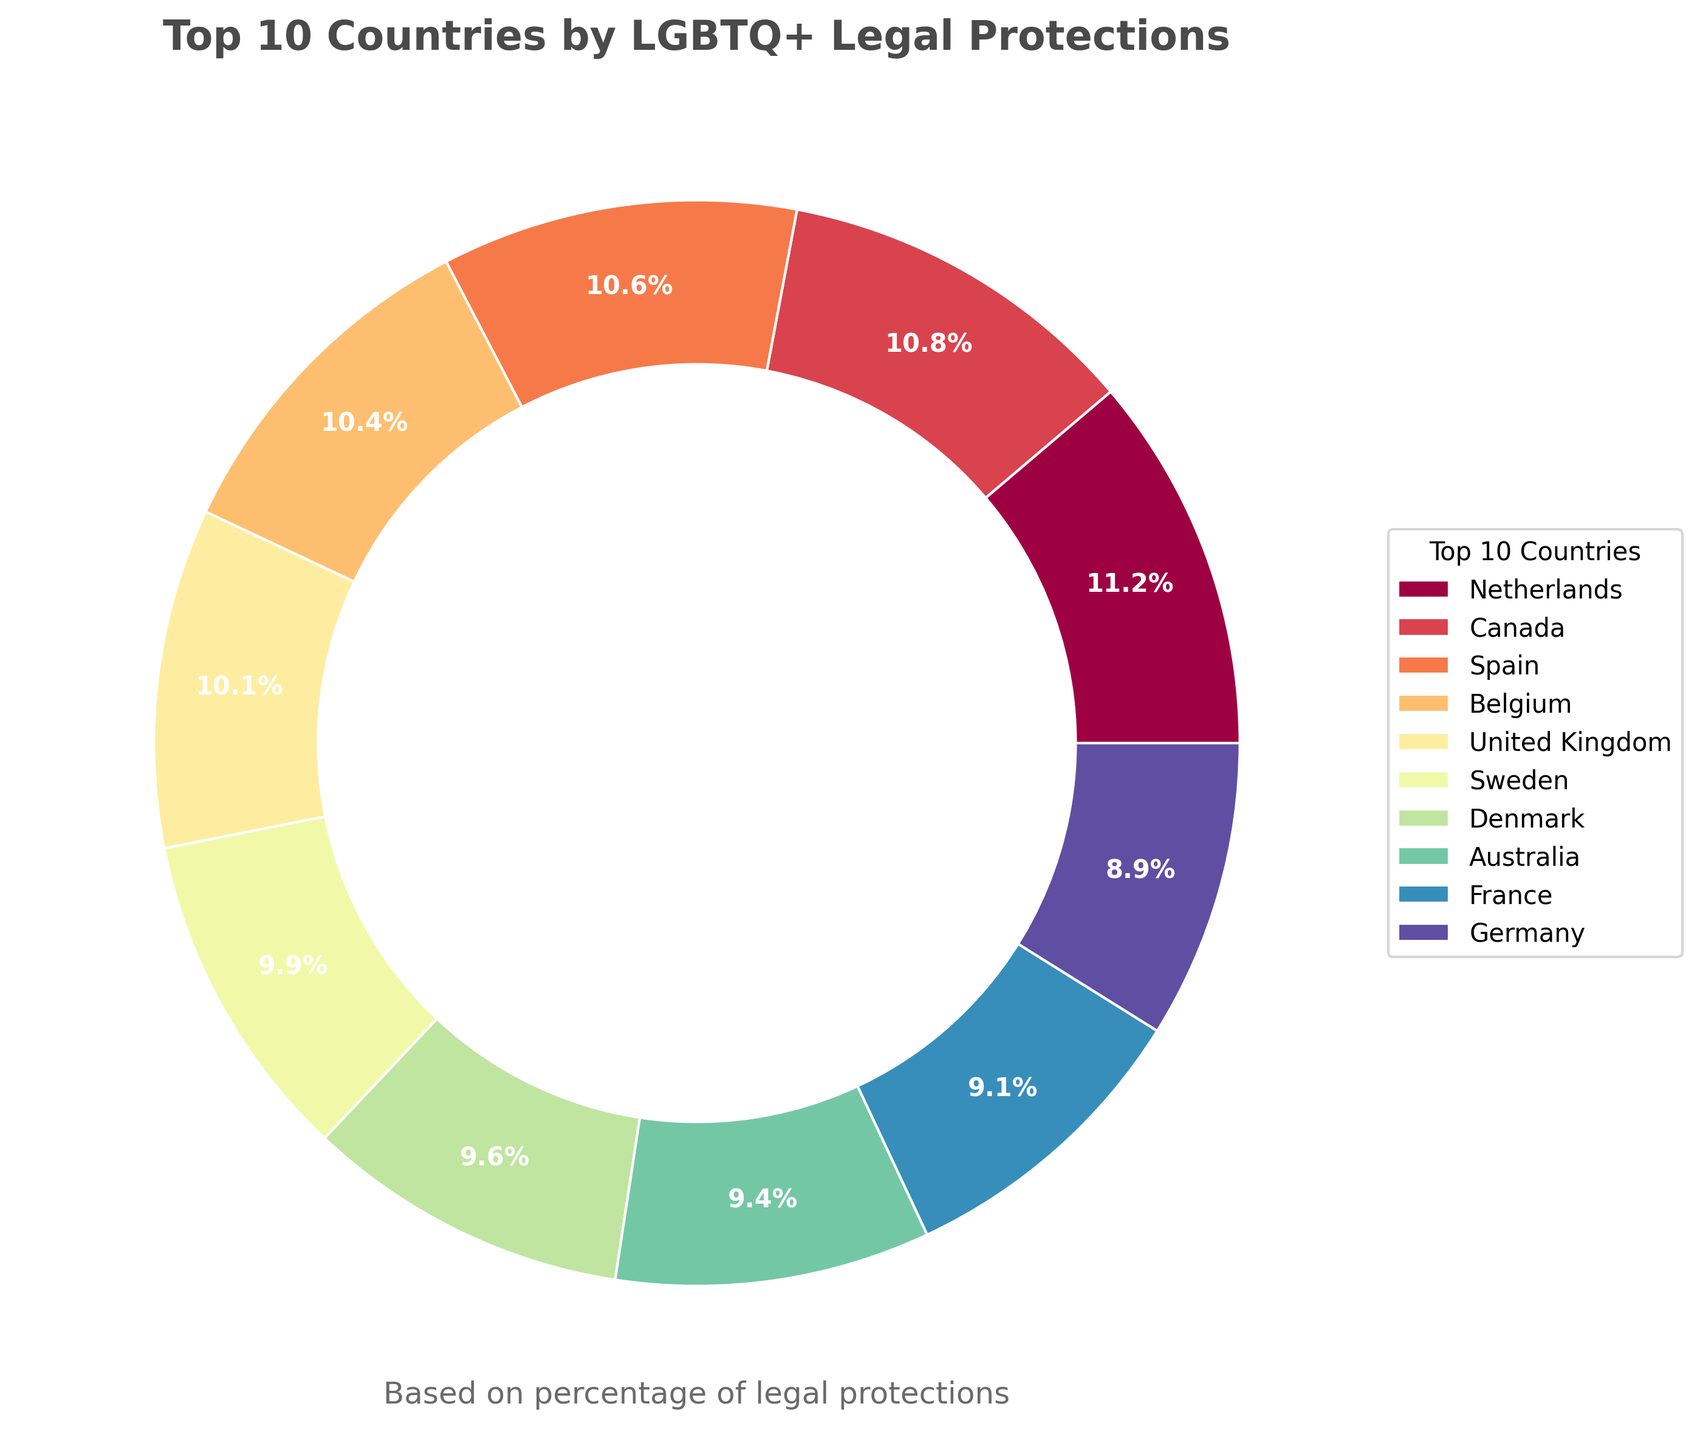Which country has the highest percentage of LGBTQ+ legal protections in the top 10 countries? First, identify the country with the highest percentage value in the pie chart. Look for the country listed first in the legend. The Netherlands is shown as having the highest percentage.
Answer: Netherlands What's the combined percentage of LGBTQ+ legal protections for Canada and Spain in the top 10 countries? First, find Canada and Spain in the chart. Canada has 89% and Spain has 87%. Add these two percentages: 89% + 87% = 176%.
Answer: 176% How does the percentage of LGBTQ+ legal protections in Australia compare to that in Denmark in the top 10 countries? Locate both Australia and Denmark in the pie chart. Australia's percentage is 77% and Denmark's is 79%. Compare the two values to see that Denmark's is slightly higher than Australia's.
Answer: Denmark's is higher Which country in the top 10 has the least percentage of LGBTQ+ legal protections? Identify the country with the smallest percentage value among the top 10 countries. This is likely to be found towards the end of the legend. Germany has the least percentage.
Answer: Germany What is the average percentage of LGBTQ+ legal protections in the top 10 countries? List the percentages of the top 10 countries: 92, 89, 87, 85, 83, 81, 79, 77, 75, 73. Sum these values: 92 + 89 + 87 + 85 + 83 + 81 + 79 + 77 + 75 + 73 = 821. Divide this sum by 10 to get the average: 821 / 10 = 82.1%.
Answer: 82.1% Compare the sum of LGBTQ+ legal protections percentages in the top 3 countries to the sum in the bottom 3 countries of the top 10. Identify the top 3 countries (Netherlands, Canada, Spain) and their percentages: 92, 89, 87. Sum these values: 92 + 89 + 87 = 268. Identify the bottom 3 countries (Germany, France, Australia) and their percentages: 73, 75, 77. Sum these values: 73 + 75 + 77 = 225. Compare the two sums: 268 is greater than 225.
Answer: Top 3's sum is higher What color represents Sweden in the pie chart? Locate Sweden in the legend and note the corresponding color. In this chart, Sweden is placed centrally, and its slice is visually distinctive by its specific color. As per the Spectral colormap, which shades from dark red to dark blue, the specific color needs to be described as seen.
Answer: Mid-range color, e.g., orange Which two countries have a difference of exactly 2% in their LGBTQ+ legal protections within the top 10? Go through the percentages and check each pair to see which have a 2% difference. Denmark (79%) and Australia (77%) are two countries with exactly a 2% difference.
Answer: Denmark and Australia What's the median percentage value of LGBTQ+ legal protections in the top 10 countries? List the percentages in ascending order: 73, 75, 77, 79, 81, 83, 85, 87, 89, 92. Since there are 10 values, the median will be the average of the 5th and 6th values: (81 + 83) / 2 = 82%.
Answer: 82% Compare the percentage of LGBTQ+ legal protections between France and the United Kingdom within the top 10 countries. Locate both France and the United Kingdom in the top 10 list and note their percentages: France is 75% and the United Kingdom is 83%. Compare these values to find that the United Kingdom's is higher.
Answer: United Kingdom's is higher 